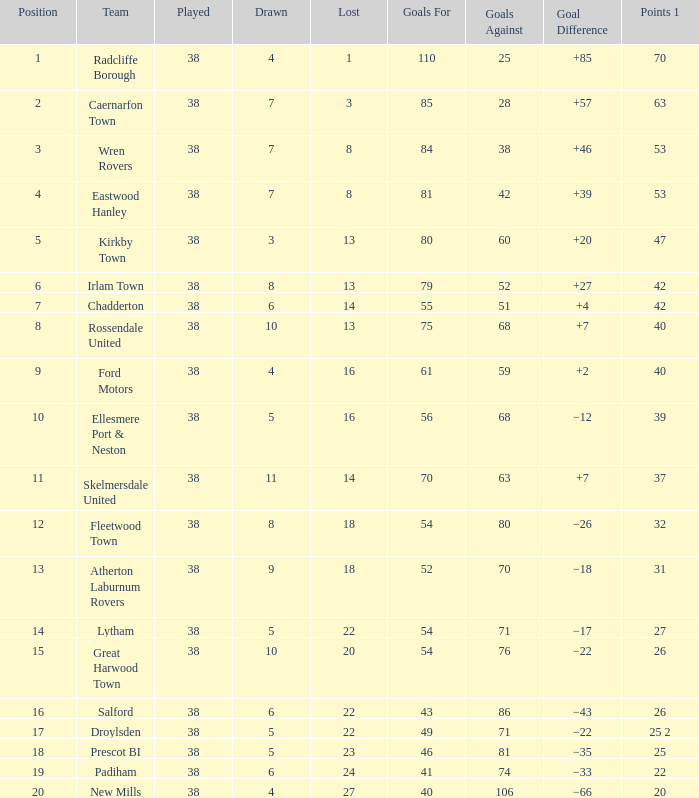Which position has 52 goals for and more than 70 goals against? None. 